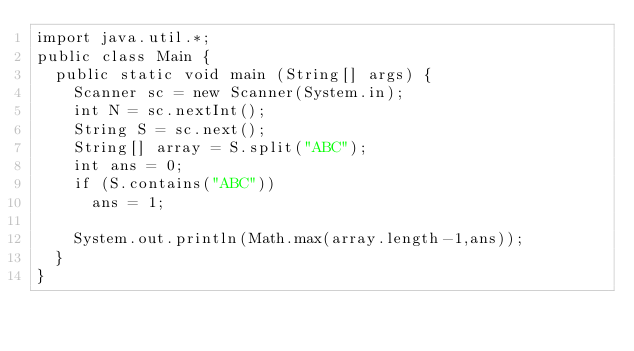Convert code to text. <code><loc_0><loc_0><loc_500><loc_500><_Java_>import java.util.*;
public class Main {
  public static void main (String[] args) {
    Scanner sc = new Scanner(System.in);
    int N = sc.nextInt();
    String S = sc.next();
    String[] array = S.split("ABC");
    int ans = 0;
    if (S.contains("ABC")) 
    	ans = 1;

    System.out.println(Math.max(array.length-1,ans));
  }
}</code> 